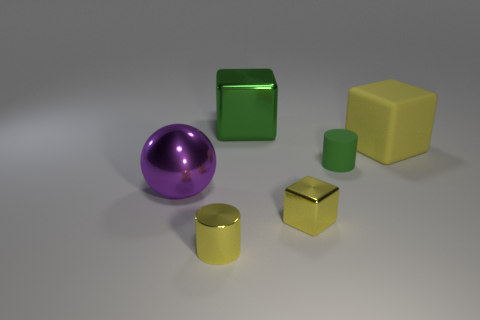The big cube that is the same material as the green cylinder is what color?
Provide a succinct answer. Yellow. Is the number of big yellow objects that are in front of the metal sphere less than the number of large shiny objects in front of the matte cylinder?
Ensure brevity in your answer.  Yes. How many big metal blocks have the same color as the small matte thing?
Your answer should be very brief. 1. What material is the block that is the same color as the tiny rubber cylinder?
Provide a succinct answer. Metal. How many objects are to the right of the tiny yellow cube and in front of the large yellow matte object?
Your answer should be very brief. 1. What material is the green thing in front of the big thing that is behind the large yellow thing?
Give a very brief answer. Rubber. Are there any red cubes that have the same material as the yellow cylinder?
Your answer should be very brief. No. There is a purple thing that is the same size as the yellow matte thing; what is its material?
Give a very brief answer. Metal. There is a cube that is behind the yellow cube that is behind the small yellow thing that is on the right side of the yellow cylinder; how big is it?
Provide a succinct answer. Large. There is a tiny yellow shiny object to the right of the small yellow cylinder; are there any large yellow objects that are to the left of it?
Your answer should be compact. No. 